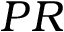Convert formula to latex. <formula><loc_0><loc_0><loc_500><loc_500>P R</formula> 